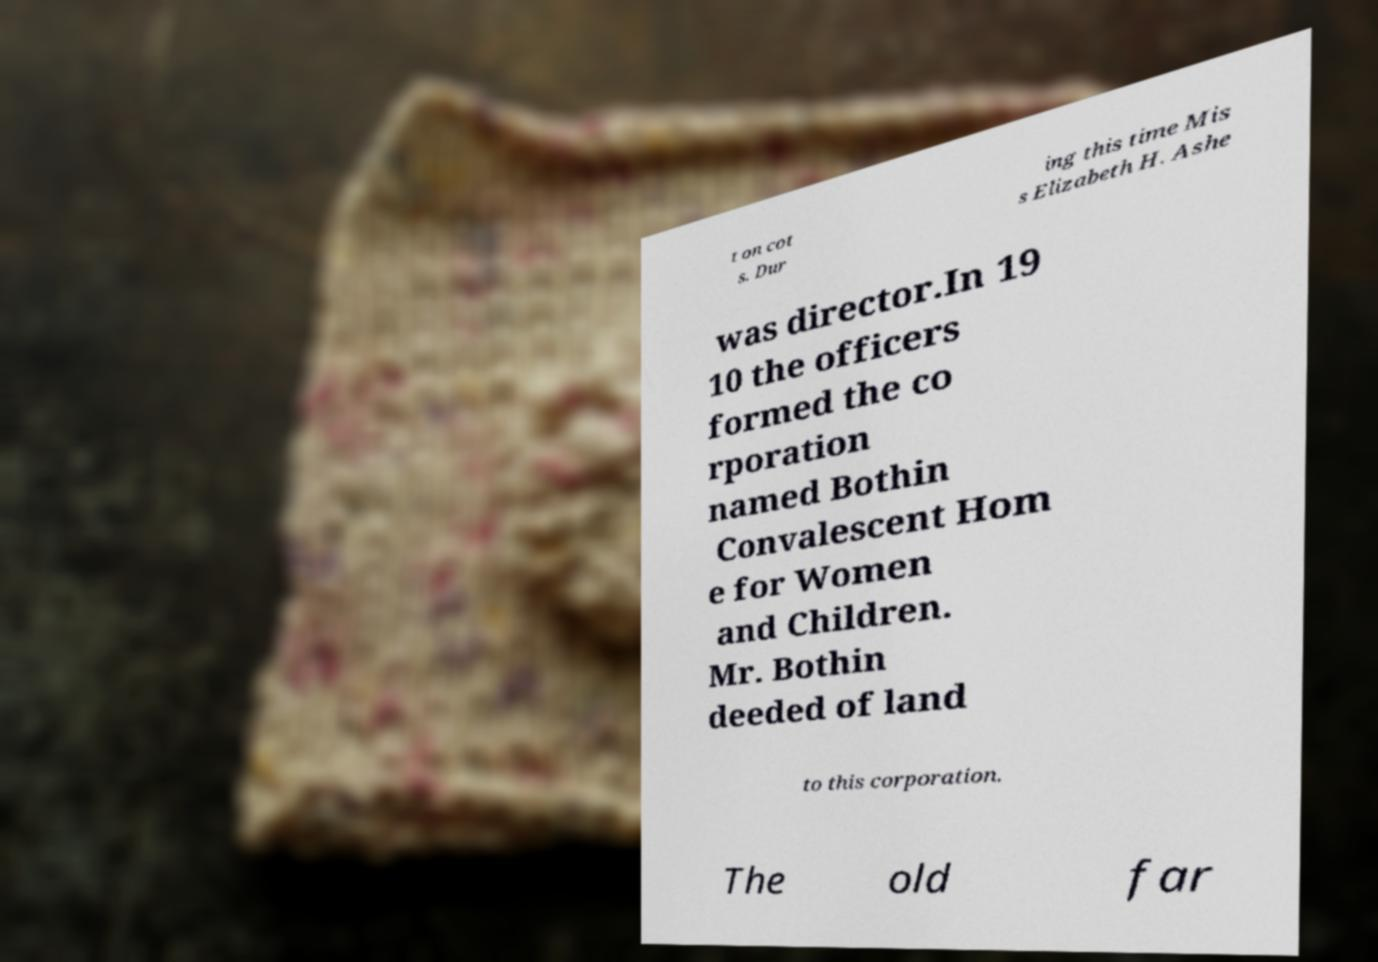Could you assist in decoding the text presented in this image and type it out clearly? t on cot s. Dur ing this time Mis s Elizabeth H. Ashe was director.In 19 10 the officers formed the co rporation named Bothin Convalescent Hom e for Women and Children. Mr. Bothin deeded of land to this corporation. The old far 